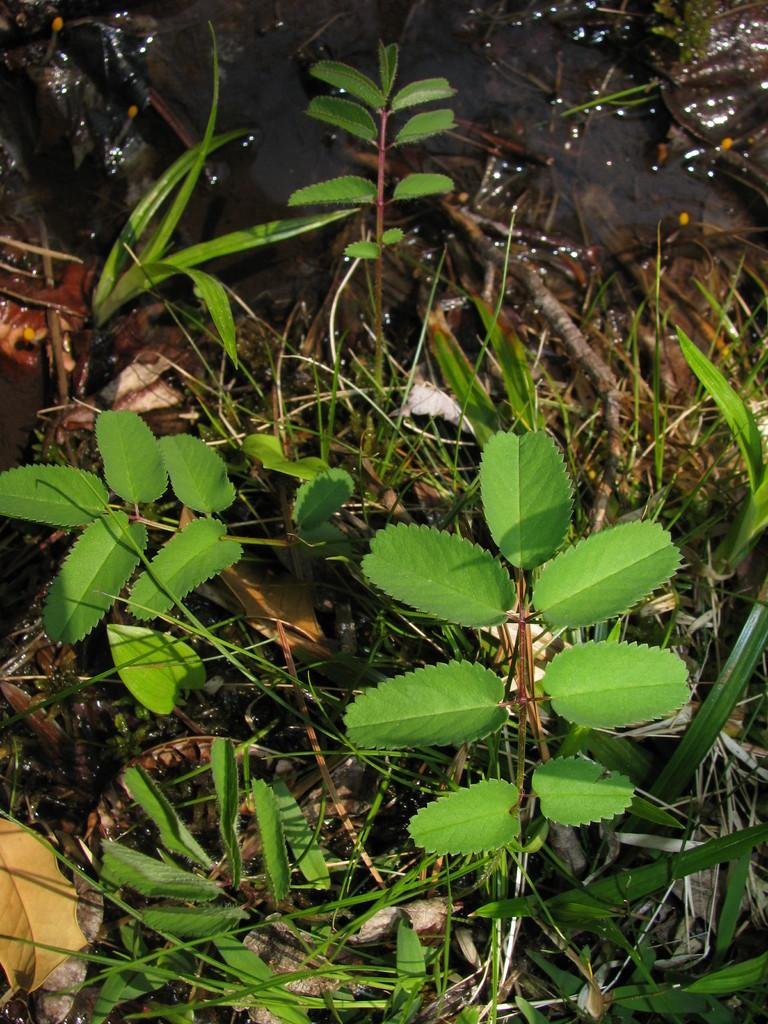What type of vegetation can be seen in the image? There are leaves and dry grass in the image. Where are the leaves and dry grass located? The leaves and dry grass are on the land. What type of boat is floating in the current in the image? There is no boat or current present in the image; it features leaves and dry grass on the land. 